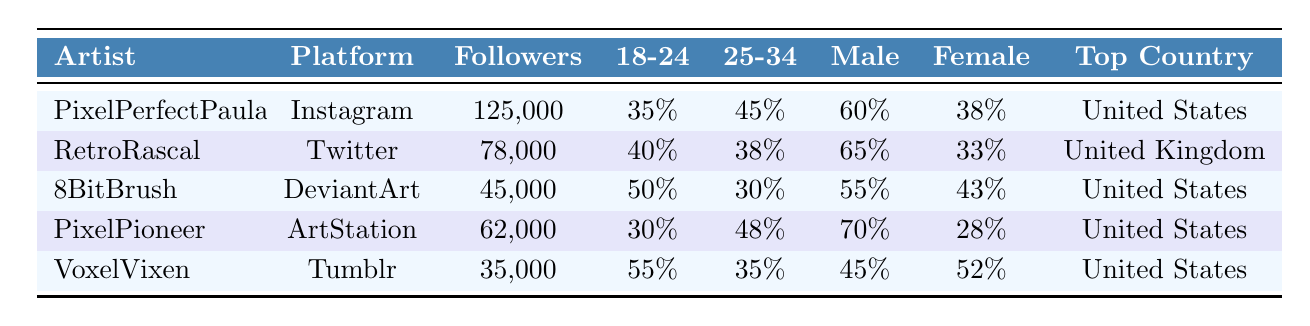What is the total number of followers for PixelPerfectPaula? The table shows that PixelPerfectPaula has 125,000 total followers listed directly under that column.
Answer: 125,000 Which platform has the most followers? By comparing the 'Followers' column values, Instagram has 125,000 followers, which is the highest among all artists listed.
Answer: Instagram What percentage of RetroRascal's followers are male? The table provides the male percentage for RetroRascal as 65% in the respective column.
Answer: 65% How many followers does VoxelVixen have compared to PixelPioneer? VoxelVixen has 35,000 followers and PixelPioneer has 62,000; subtracting 35,000 from 62,000 shows that PixelPioneer has 27,000 more followers.
Answer: 27,000 Which artist has the highest percentage of young followers aged 18-24? By examining the '18-24' column, VoxelVixen has the highest percentage at 55%.
Answer: VoxelVixen Is the top country for all artists the United States? The data indicates that both PixelPerfectPaula, 8BitBrush, PixelPioneer, and VoxelVixen have the United States as their top country, so the statement is true for those artists but false for RetroRascal, whose top country is the United Kingdom.
Answer: No Calculate the average percentage of female followers across all artists. The female percentages are 38%, 33%, 43%, 28%, and 52%. Summing these up gives 192%, dividing by 5 gives an average of 38.4%.
Answer: 38.4% Which artist has the highest female follower percentage? Looking at the 'Female' percentage column, VoxelVixen has the highest percentage at 52%.
Answer: VoxelVixen How many male followers does 8BitBrush have? To find the number of male followers for 8BitBrush, multiply the total followers (45,000) by the male percentage (55%), which equals 24,750 male followers.
Answer: 24,750 What is the combined total of followers for artists on Instagram and DeviantArt? Calculating the followers, PixelPerfectPaula on Instagram has 125,000 and 8BitBrush on DeviantArt has 45,000. Their combined total is 125,000 + 45,000 = 170,000.
Answer: 170,000 